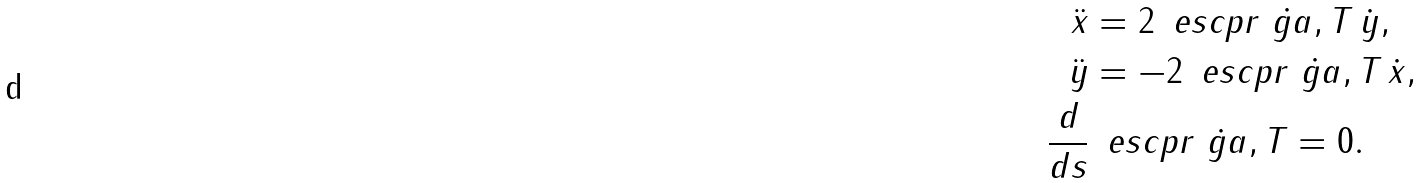Convert formula to latex. <formula><loc_0><loc_0><loc_500><loc_500>\ddot { x } & = 2 \, \ e s c p r { \dot { \ g a } , T } \, \dot { y } , \\ \ddot { y } & = - 2 \, \ e s c p r { \dot { \ g a } , T } \, \dot { x } , \\ \frac { d } { d s } & \, \ e s c p r { \dot { \ g a } , T } = 0 .</formula> 